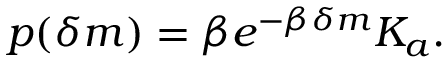Convert formula to latex. <formula><loc_0><loc_0><loc_500><loc_500>p ( \delta m ) = \beta e ^ { - \beta \delta m } K _ { a } .</formula> 